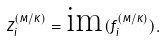Convert formula to latex. <formula><loc_0><loc_0><loc_500><loc_500>Z _ { i } ^ { ( M / K ) } = \text {im} ( f _ { i } ^ { ( M / K ) } ) .</formula> 